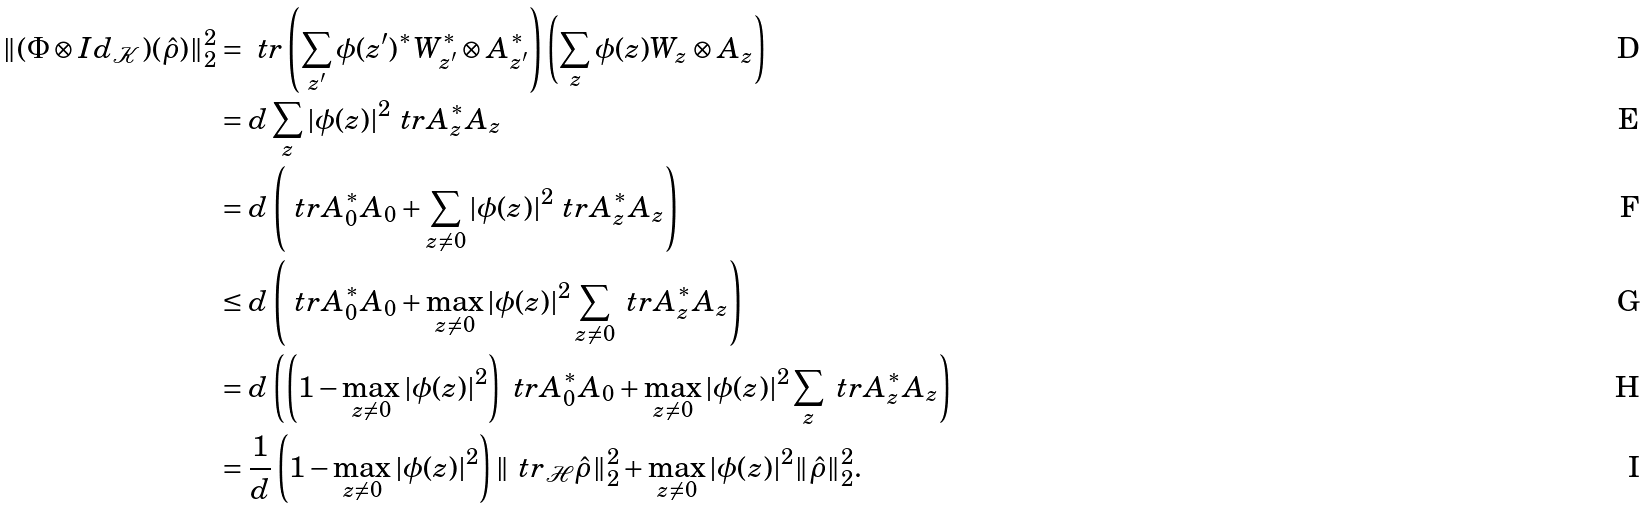Convert formula to latex. <formula><loc_0><loc_0><loc_500><loc_500>\| ( \Phi \otimes I d _ { \mathcal { K } } ) ( \hat { \rho } ) \| _ { 2 } ^ { 2 } & = \ t r \left ( \sum _ { z ^ { \prime } } \phi ( z ^ { \prime } ) ^ { \ast } W _ { z ^ { \prime } } ^ { \ast } \otimes A _ { z ^ { \prime } } ^ { \ast } \right ) \left ( \sum _ { z } \phi ( z ) W _ { z } \otimes A _ { z } \right ) \\ & = d \sum _ { z } | \phi ( z ) | ^ { 2 } \ t r A _ { z } ^ { \ast } A _ { z } \\ & = d \left ( \ t r A _ { 0 } ^ { \ast } A _ { 0 } + \sum _ { z \neq 0 } | \phi ( z ) | ^ { 2 } \ t r A _ { z } ^ { \ast } A _ { z } \right ) \\ & \leq d \left ( \ t r A _ { 0 } ^ { \ast } A _ { 0 } + \max _ { z \neq 0 } | \phi ( z ) | ^ { 2 } \sum _ { z \neq 0 } \ t r A _ { z } ^ { \ast } A _ { z } \right ) \\ & = d \left ( \left ( 1 - \max _ { z \neq 0 } | \phi ( z ) | ^ { 2 } \right ) \ t r A _ { 0 } ^ { \ast } A _ { 0 } + \max _ { z \neq 0 } | \phi ( z ) | ^ { 2 } \sum _ { z } \ t r A _ { z } ^ { \ast } A _ { z } \right ) \\ & = \frac { 1 } { d } \left ( 1 - \max _ { z \neq 0 } | \phi ( z ) | ^ { 2 } \right ) \| \ t r _ { \mathcal { H } } \hat { \rho } \| _ { 2 } ^ { 2 } + \max _ { z \neq 0 } | \phi ( z ) | ^ { 2 } \| \hat { \rho } \| _ { 2 } ^ { 2 } .</formula> 